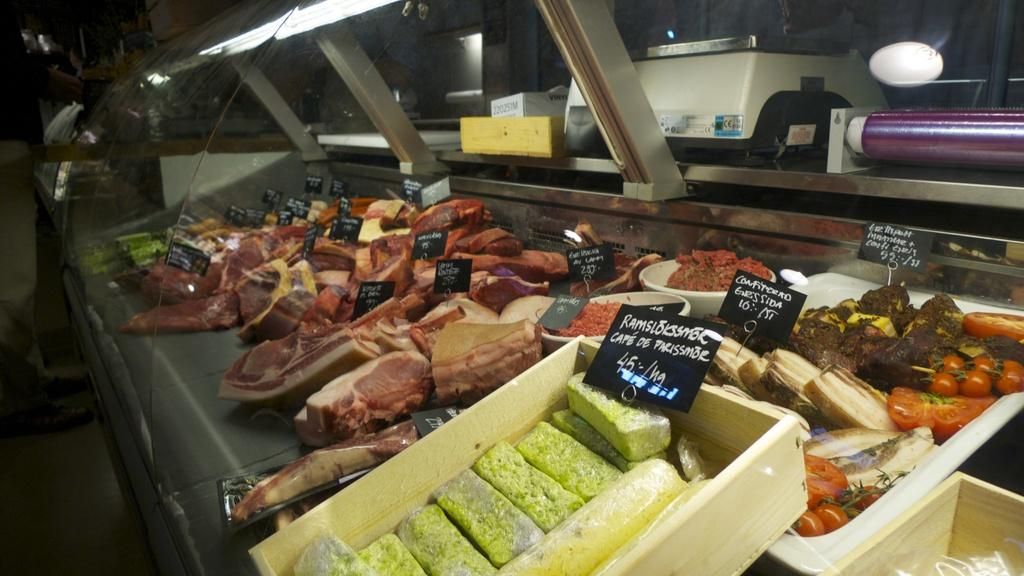What type of objects can be seen in the image? There are food items in the image. Where are the food items located? The food items are present over a place. What can be seen above the food items? There are lights present above the food items. How many trains can be seen passing by the food items in the image? There are no trains present in the image; it only features food items and lights. 